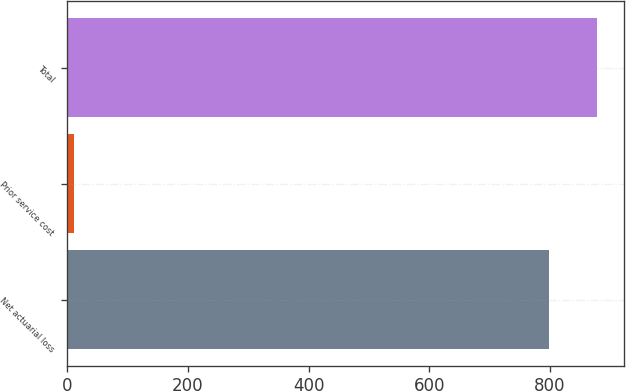Convert chart to OTSL. <chart><loc_0><loc_0><loc_500><loc_500><bar_chart><fcel>Net actuarial loss<fcel>Prior service cost<fcel>Total<nl><fcel>798.2<fcel>11.7<fcel>878.02<nl></chart> 